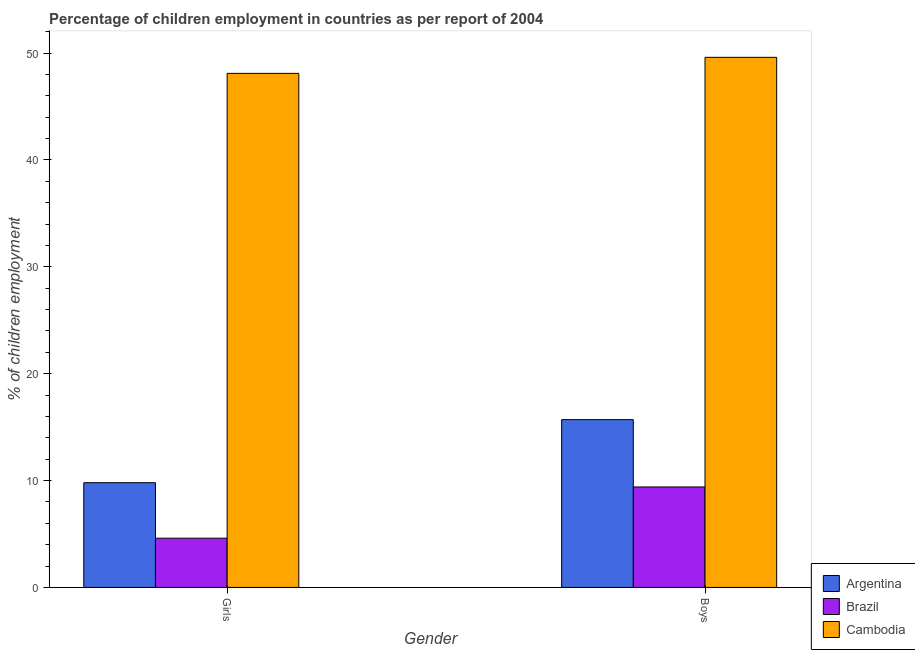How many different coloured bars are there?
Give a very brief answer. 3. How many bars are there on the 2nd tick from the right?
Keep it short and to the point. 3. What is the label of the 2nd group of bars from the left?
Provide a short and direct response. Boys. What is the percentage of employed girls in Argentina?
Give a very brief answer. 9.8. Across all countries, what is the maximum percentage of employed boys?
Your answer should be very brief. 49.6. Across all countries, what is the minimum percentage of employed boys?
Make the answer very short. 9.4. In which country was the percentage of employed girls maximum?
Make the answer very short. Cambodia. What is the total percentage of employed boys in the graph?
Your answer should be compact. 74.7. What is the difference between the percentage of employed boys in Cambodia and that in Brazil?
Keep it short and to the point. 40.2. What is the difference between the percentage of employed girls in Brazil and the percentage of employed boys in Cambodia?
Your answer should be very brief. -44.99. What is the average percentage of employed girls per country?
Your response must be concise. 20.84. What is the difference between the percentage of employed girls and percentage of employed boys in Cambodia?
Ensure brevity in your answer.  -1.5. In how many countries, is the percentage of employed boys greater than 32 %?
Offer a terse response. 1. What is the ratio of the percentage of employed girls in Cambodia to that in Brazil?
Your answer should be very brief. 10.44. Is the percentage of employed boys in Cambodia less than that in Argentina?
Give a very brief answer. No. What does the 1st bar from the left in Boys represents?
Ensure brevity in your answer.  Argentina. What does the 2nd bar from the right in Boys represents?
Give a very brief answer. Brazil. How many bars are there?
Your answer should be compact. 6. What is the difference between two consecutive major ticks on the Y-axis?
Keep it short and to the point. 10. Are the values on the major ticks of Y-axis written in scientific E-notation?
Provide a succinct answer. No. Does the graph contain any zero values?
Offer a terse response. No. Where does the legend appear in the graph?
Provide a succinct answer. Bottom right. What is the title of the graph?
Give a very brief answer. Percentage of children employment in countries as per report of 2004. Does "Vietnam" appear as one of the legend labels in the graph?
Your response must be concise. No. What is the label or title of the X-axis?
Keep it short and to the point. Gender. What is the label or title of the Y-axis?
Provide a succinct answer. % of children employment. What is the % of children employment of Argentina in Girls?
Provide a succinct answer. 9.8. What is the % of children employment of Brazil in Girls?
Your answer should be very brief. 4.61. What is the % of children employment of Cambodia in Girls?
Keep it short and to the point. 48.1. What is the % of children employment of Argentina in Boys?
Your response must be concise. 15.7. What is the % of children employment of Cambodia in Boys?
Your answer should be compact. 49.6. Across all Gender, what is the maximum % of children employment of Cambodia?
Provide a succinct answer. 49.6. Across all Gender, what is the minimum % of children employment in Argentina?
Make the answer very short. 9.8. Across all Gender, what is the minimum % of children employment of Brazil?
Ensure brevity in your answer.  4.61. Across all Gender, what is the minimum % of children employment in Cambodia?
Your response must be concise. 48.1. What is the total % of children employment of Brazil in the graph?
Keep it short and to the point. 14.01. What is the total % of children employment in Cambodia in the graph?
Provide a short and direct response. 97.7. What is the difference between the % of children employment in Brazil in Girls and that in Boys?
Offer a terse response. -4.79. What is the difference between the % of children employment in Argentina in Girls and the % of children employment in Cambodia in Boys?
Your response must be concise. -39.8. What is the difference between the % of children employment of Brazil in Girls and the % of children employment of Cambodia in Boys?
Your answer should be very brief. -44.99. What is the average % of children employment in Argentina per Gender?
Ensure brevity in your answer.  12.75. What is the average % of children employment in Brazil per Gender?
Offer a very short reply. 7. What is the average % of children employment in Cambodia per Gender?
Ensure brevity in your answer.  48.85. What is the difference between the % of children employment in Argentina and % of children employment in Brazil in Girls?
Offer a very short reply. 5.19. What is the difference between the % of children employment in Argentina and % of children employment in Cambodia in Girls?
Give a very brief answer. -38.3. What is the difference between the % of children employment of Brazil and % of children employment of Cambodia in Girls?
Make the answer very short. -43.49. What is the difference between the % of children employment of Argentina and % of children employment of Brazil in Boys?
Give a very brief answer. 6.3. What is the difference between the % of children employment of Argentina and % of children employment of Cambodia in Boys?
Provide a succinct answer. -33.9. What is the difference between the % of children employment in Brazil and % of children employment in Cambodia in Boys?
Ensure brevity in your answer.  -40.2. What is the ratio of the % of children employment in Argentina in Girls to that in Boys?
Offer a terse response. 0.62. What is the ratio of the % of children employment in Brazil in Girls to that in Boys?
Provide a short and direct response. 0.49. What is the ratio of the % of children employment of Cambodia in Girls to that in Boys?
Give a very brief answer. 0.97. What is the difference between the highest and the second highest % of children employment in Argentina?
Your response must be concise. 5.9. What is the difference between the highest and the second highest % of children employment in Brazil?
Provide a short and direct response. 4.79. What is the difference between the highest and the lowest % of children employment of Argentina?
Keep it short and to the point. 5.9. What is the difference between the highest and the lowest % of children employment in Brazil?
Make the answer very short. 4.79. What is the difference between the highest and the lowest % of children employment of Cambodia?
Offer a very short reply. 1.5. 